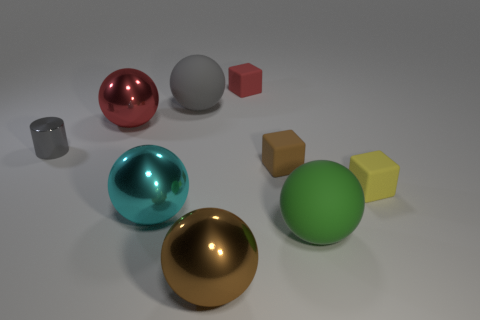Describe the lighting setup in this image. The lighting in the image seems to be coming from a high angle, possibly from above and slightly to the right, as indicated by the shadows cast to the lower left of the objects and the highlights on the upper right of the surfaces. 